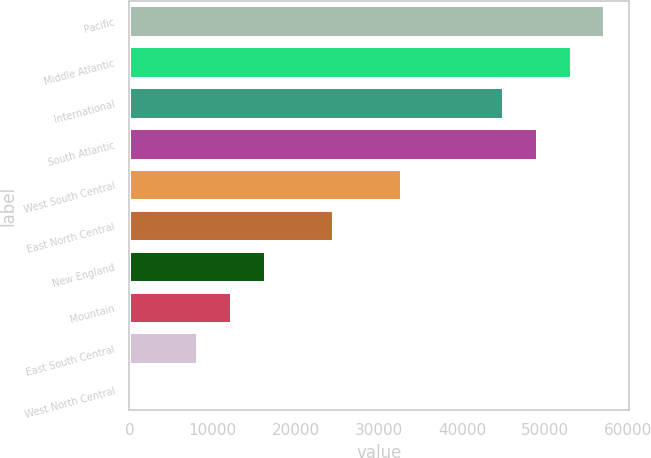Convert chart to OTSL. <chart><loc_0><loc_0><loc_500><loc_500><bar_chart><fcel>Pacific<fcel>Middle Atlantic<fcel>International<fcel>South Atlantic<fcel>West South Central<fcel>East North Central<fcel>New England<fcel>Mountain<fcel>East South Central<fcel>West North Central<nl><fcel>57237.2<fcel>53159.4<fcel>45003.8<fcel>49081.6<fcel>32770.4<fcel>24614.8<fcel>16459.2<fcel>12381.4<fcel>8303.6<fcel>148<nl></chart> 